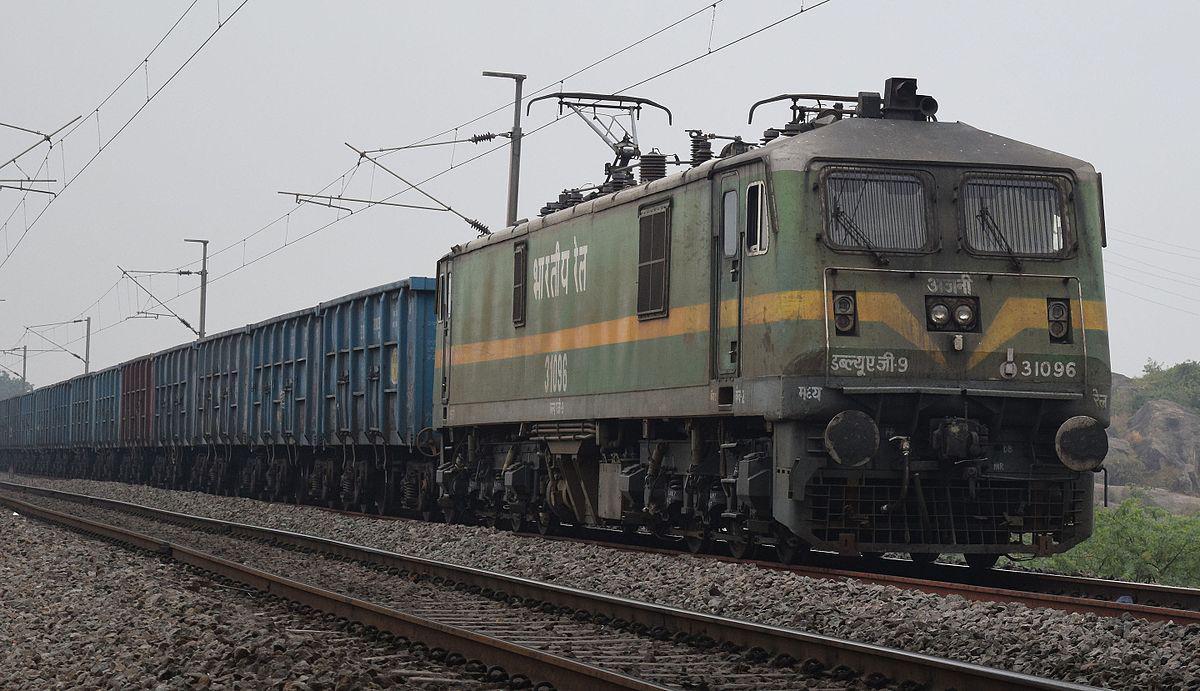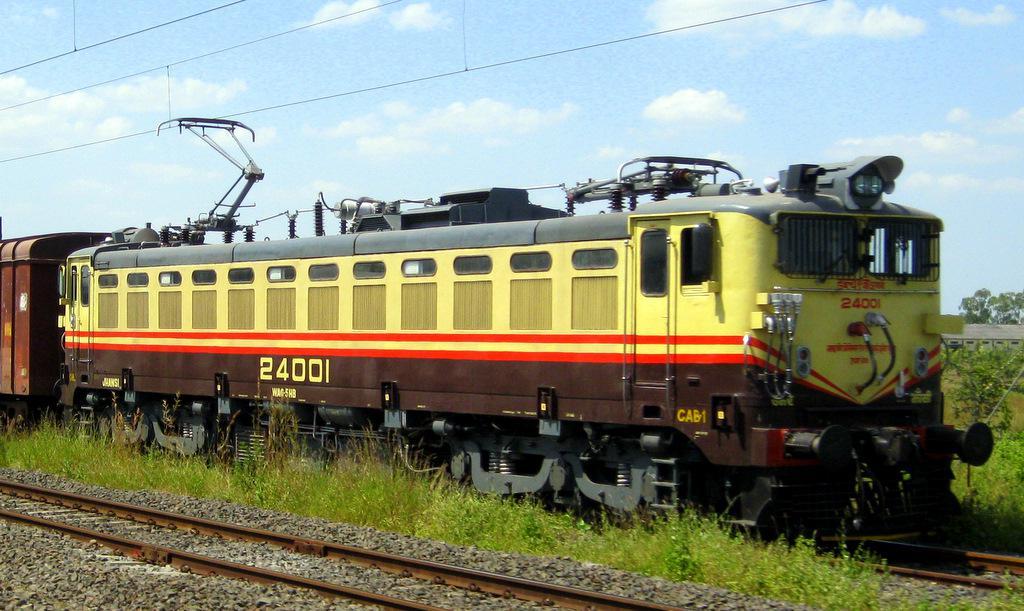The first image is the image on the left, the second image is the image on the right. Analyze the images presented: Is the assertion "The trains in both images travel on straight tracks in the same direction." valid? Answer yes or no. Yes. 